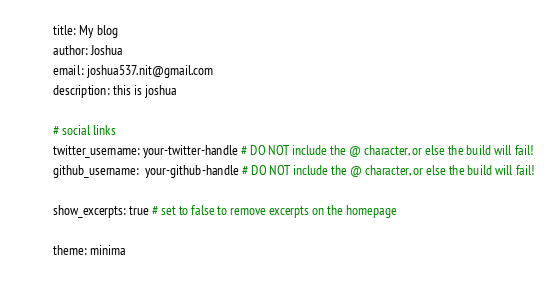<code> <loc_0><loc_0><loc_500><loc_500><_YAML_>title: My blog
author: Joshua
email: joshua537.nit@gmail.com
description: this is joshua

# social links
twitter_username: your-twitter-handle # DO NOT include the @ character, or else the build will fail!
github_username:  your-github-handle # DO NOT include the @ character, or else the build will fail!

show_excerpts: true # set to false to remove excerpts on the homepage

theme: minima
</code> 